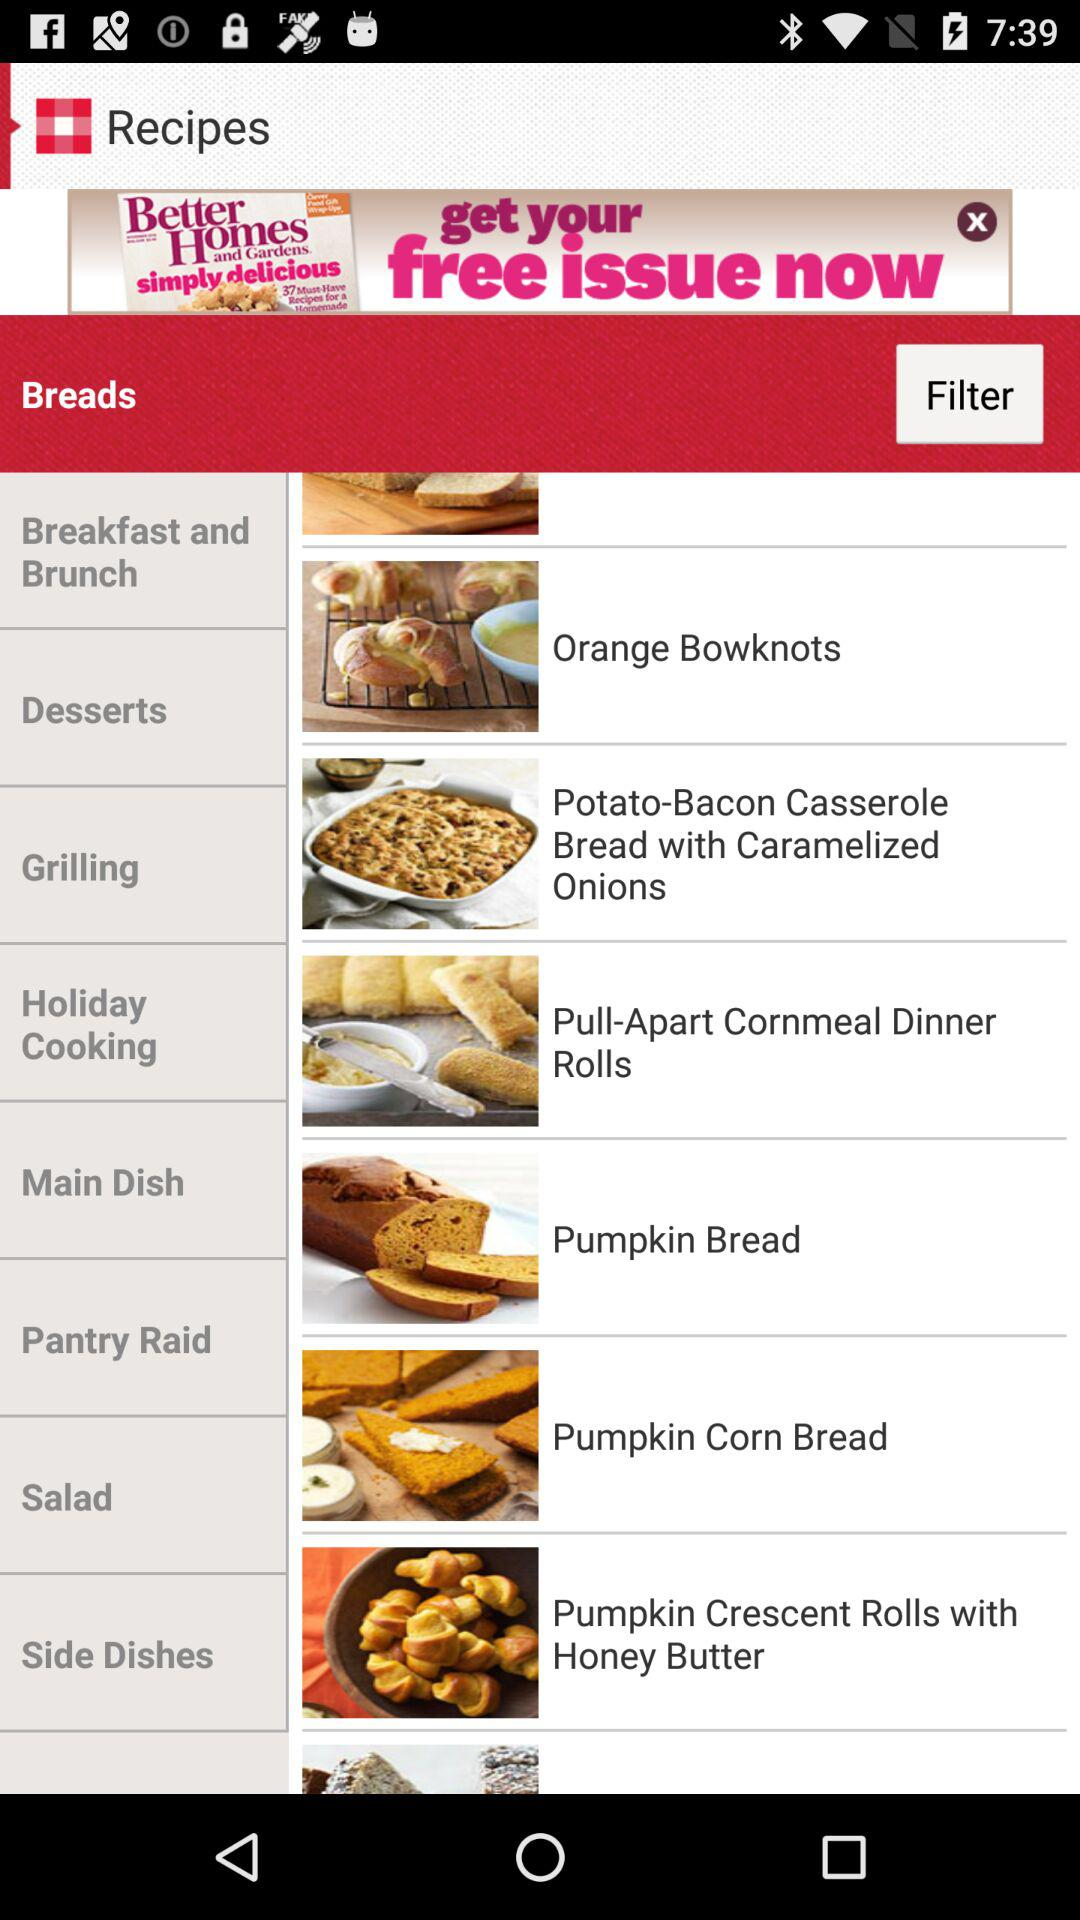What is available in "Breakfast and Brunch"?
When the provided information is insufficient, respond with <no answer>. <no answer> 